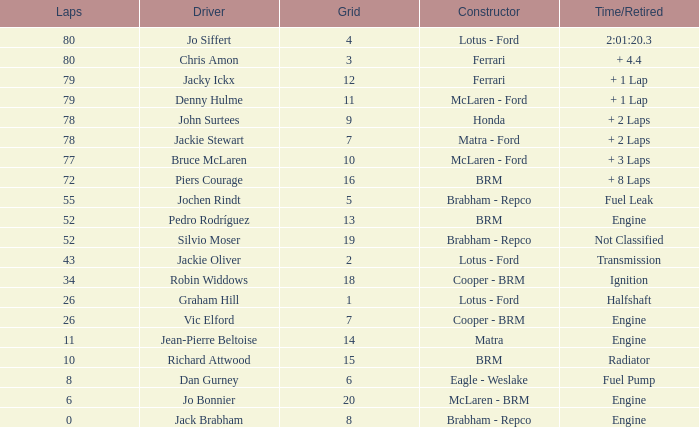What driver holds a grid exceeding 19? Jo Bonnier. 